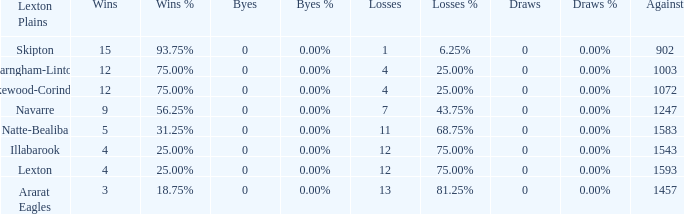What team has fewer than 9 wins and less than 1593 against? Natte-Bealiba, Illabarook, Ararat Eagles. 